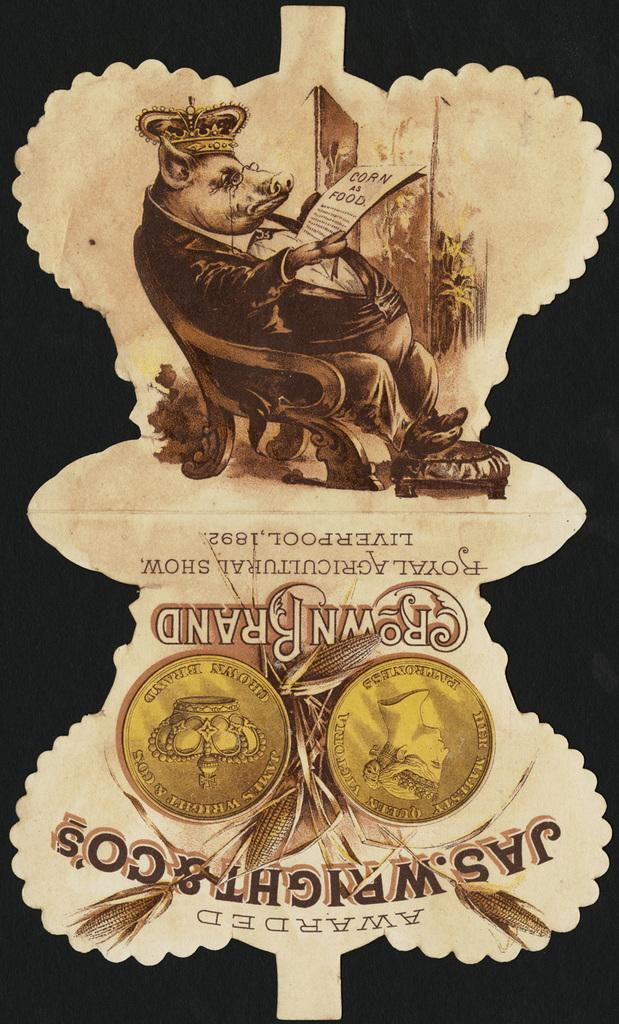<image>
Share a concise interpretation of the image provided. Label saying Crown Brand and a picture of a pig reading. 